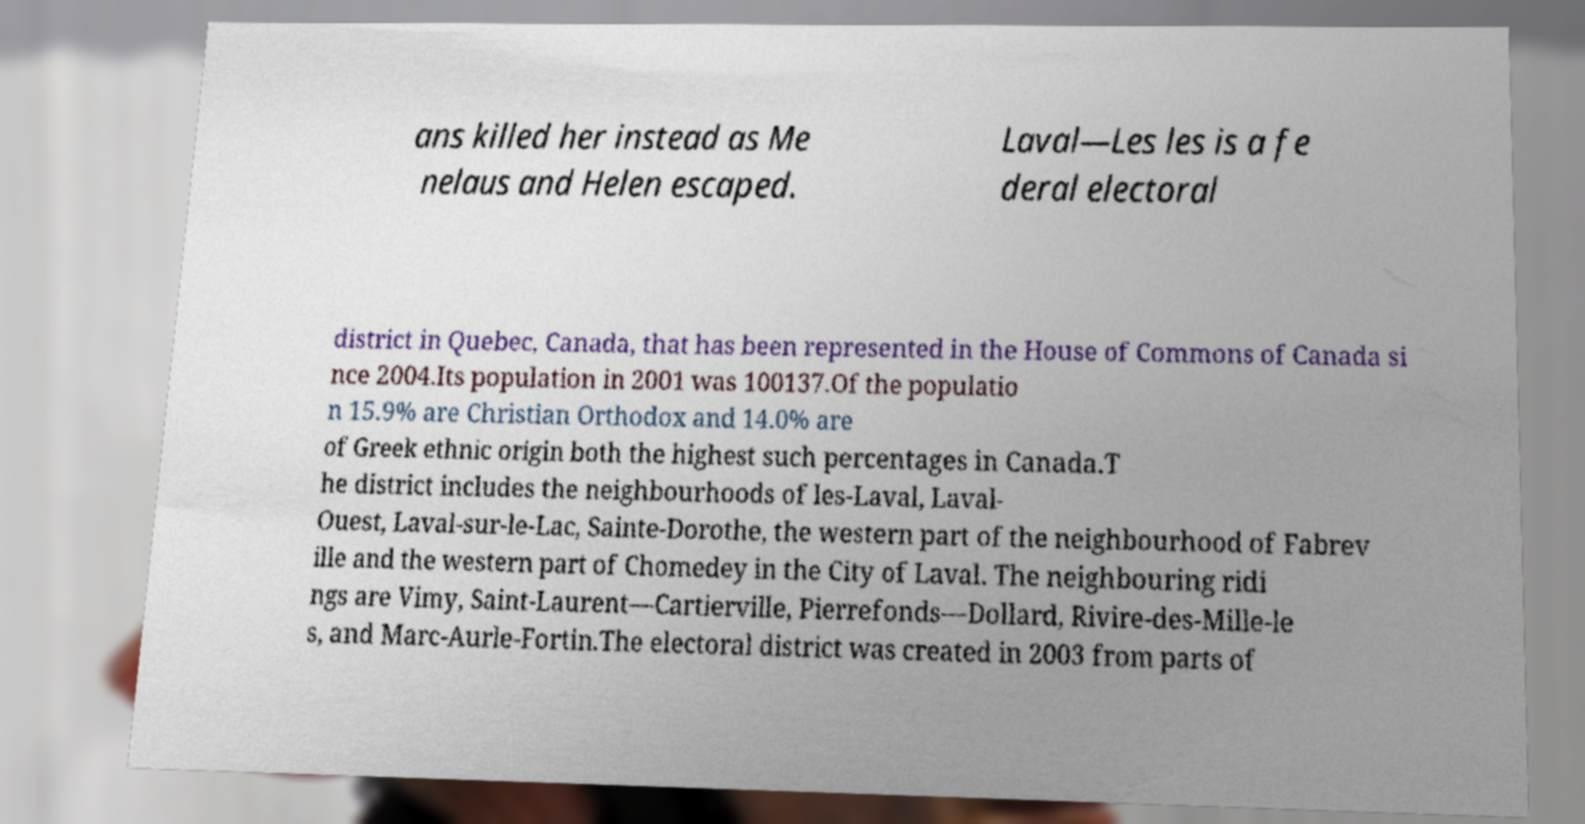Can you read and provide the text displayed in the image?This photo seems to have some interesting text. Can you extract and type it out for me? ans killed her instead as Me nelaus and Helen escaped. Laval—Les les is a fe deral electoral district in Quebec, Canada, that has been represented in the House of Commons of Canada si nce 2004.Its population in 2001 was 100137.Of the populatio n 15.9% are Christian Orthodox and 14.0% are of Greek ethnic origin both the highest such percentages in Canada.T he district includes the neighbourhoods of les-Laval, Laval- Ouest, Laval-sur-le-Lac, Sainte-Dorothe, the western part of the neighbourhood of Fabrev ille and the western part of Chomedey in the City of Laval. The neighbouring ridi ngs are Vimy, Saint-Laurent—Cartierville, Pierrefonds—Dollard, Rivire-des-Mille-le s, and Marc-Aurle-Fortin.The electoral district was created in 2003 from parts of 